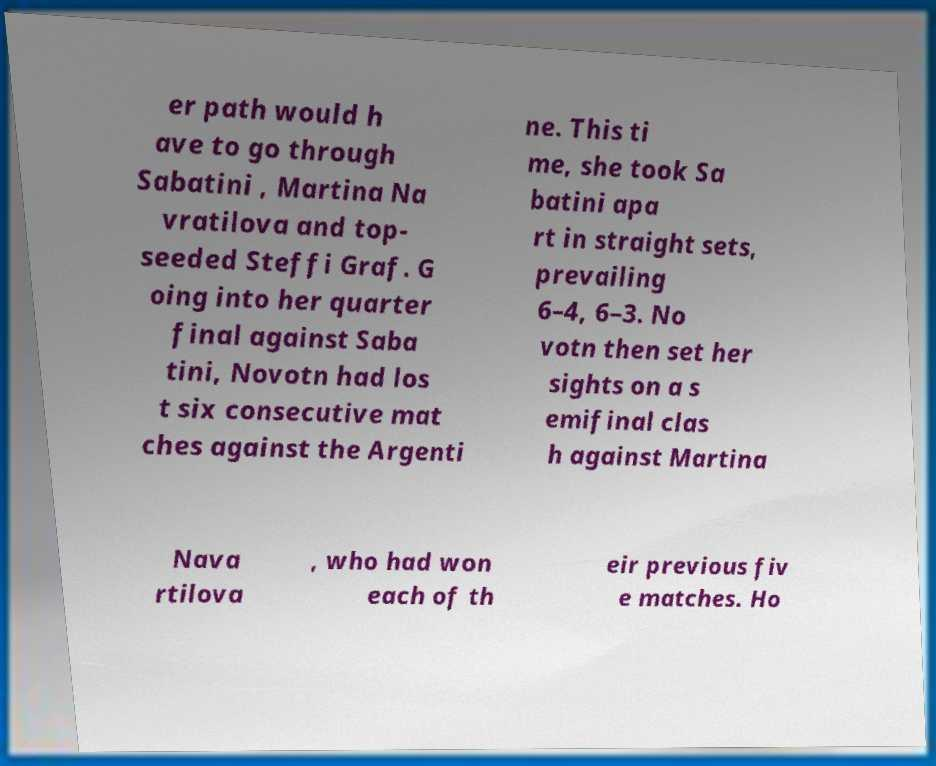I need the written content from this picture converted into text. Can you do that? er path would h ave to go through Sabatini , Martina Na vratilova and top- seeded Steffi Graf. G oing into her quarter final against Saba tini, Novotn had los t six consecutive mat ches against the Argenti ne. This ti me, she took Sa batini apa rt in straight sets, prevailing 6–4, 6–3. No votn then set her sights on a s emifinal clas h against Martina Nava rtilova , who had won each of th eir previous fiv e matches. Ho 